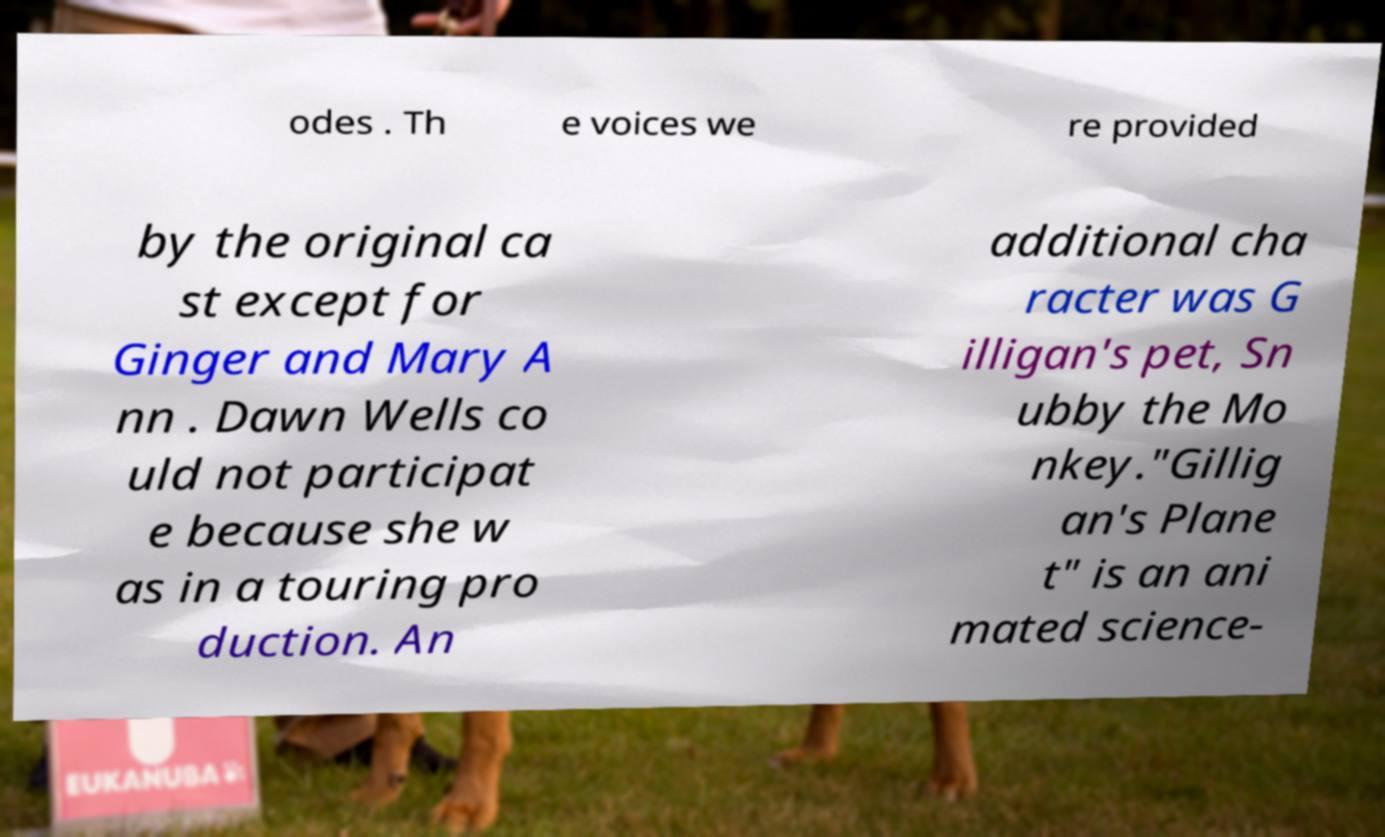Could you assist in decoding the text presented in this image and type it out clearly? odes . Th e voices we re provided by the original ca st except for Ginger and Mary A nn . Dawn Wells co uld not participat e because she w as in a touring pro duction. An additional cha racter was G illigan's pet, Sn ubby the Mo nkey."Gillig an's Plane t" is an ani mated science- 